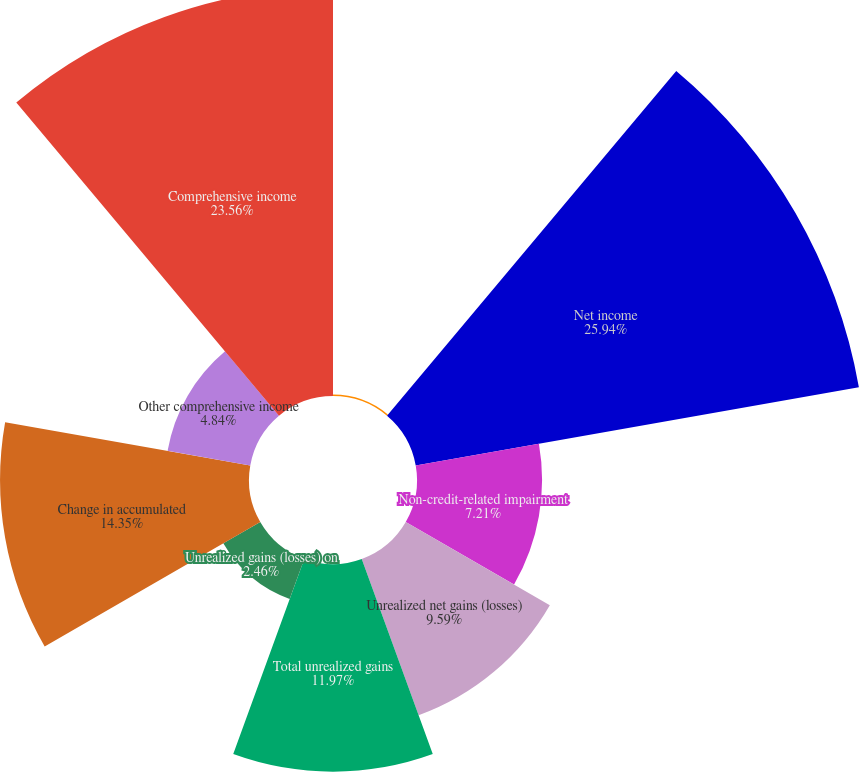Convert chart. <chart><loc_0><loc_0><loc_500><loc_500><pie_chart><fcel>(dollar amounts in thousands)<fcel>Net income<fcel>Non-credit-related impairment<fcel>Unrealized net gains (losses)<fcel>Total unrealized gains<fcel>Unrealized gains (losses) on<fcel>Change in accumulated<fcel>Other comprehensive income<fcel>Comprehensive income<nl><fcel>0.08%<fcel>25.94%<fcel>7.21%<fcel>9.59%<fcel>11.97%<fcel>2.46%<fcel>14.35%<fcel>4.84%<fcel>23.56%<nl></chart> 